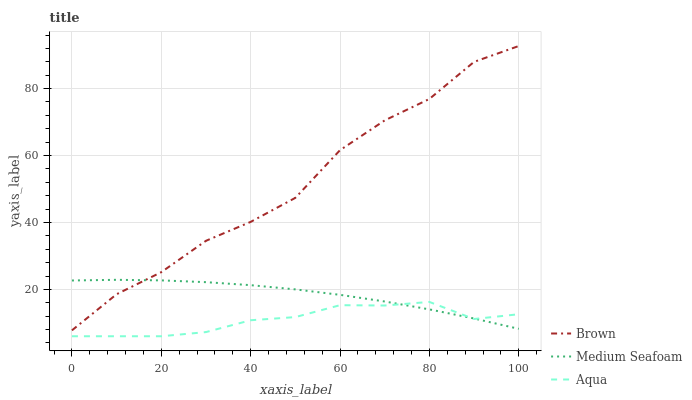Does Aqua have the minimum area under the curve?
Answer yes or no. Yes. Does Brown have the maximum area under the curve?
Answer yes or no. Yes. Does Medium Seafoam have the minimum area under the curve?
Answer yes or no. No. Does Medium Seafoam have the maximum area under the curve?
Answer yes or no. No. Is Medium Seafoam the smoothest?
Answer yes or no. Yes. Is Brown the roughest?
Answer yes or no. Yes. Is Aqua the smoothest?
Answer yes or no. No. Is Aqua the roughest?
Answer yes or no. No. Does Aqua have the lowest value?
Answer yes or no. Yes. Does Medium Seafoam have the lowest value?
Answer yes or no. No. Does Brown have the highest value?
Answer yes or no. Yes. Does Medium Seafoam have the highest value?
Answer yes or no. No. Is Aqua less than Brown?
Answer yes or no. Yes. Is Brown greater than Aqua?
Answer yes or no. Yes. Does Aqua intersect Medium Seafoam?
Answer yes or no. Yes. Is Aqua less than Medium Seafoam?
Answer yes or no. No. Is Aqua greater than Medium Seafoam?
Answer yes or no. No. Does Aqua intersect Brown?
Answer yes or no. No. 